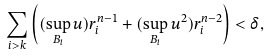<formula> <loc_0><loc_0><loc_500><loc_500>\sum _ { i > k } \left ( ( \sup _ { B _ { i } } u ) r _ { i } ^ { n - 1 } + ( \sup _ { B _ { i } } u ^ { 2 } ) r _ { i } ^ { n - 2 } \right ) < \delta ,</formula> 